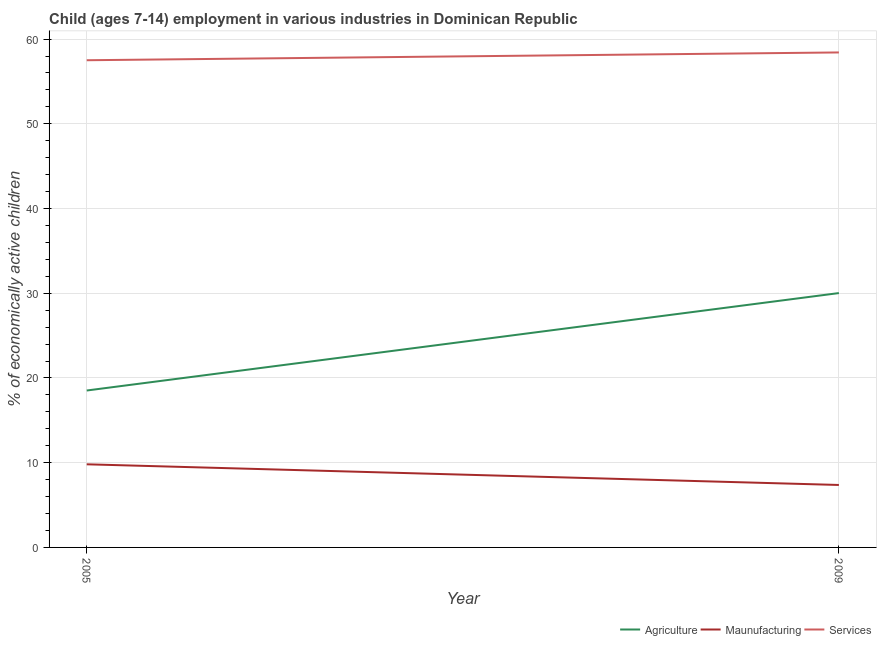How many different coloured lines are there?
Your response must be concise. 3. Does the line corresponding to percentage of economically active children in agriculture intersect with the line corresponding to percentage of economically active children in services?
Provide a succinct answer. No. What is the percentage of economically active children in agriculture in 2005?
Your answer should be very brief. 18.52. Across all years, what is the maximum percentage of economically active children in services?
Offer a very short reply. 58.42. Across all years, what is the minimum percentage of economically active children in services?
Offer a very short reply. 57.5. What is the total percentage of economically active children in manufacturing in the graph?
Your answer should be compact. 17.18. What is the difference between the percentage of economically active children in agriculture in 2005 and the percentage of economically active children in services in 2009?
Keep it short and to the point. -39.9. What is the average percentage of economically active children in services per year?
Give a very brief answer. 57.96. In the year 2009, what is the difference between the percentage of economically active children in services and percentage of economically active children in manufacturing?
Provide a succinct answer. 51.05. What is the ratio of the percentage of economically active children in agriculture in 2005 to that in 2009?
Offer a terse response. 0.62. In how many years, is the percentage of economically active children in services greater than the average percentage of economically active children in services taken over all years?
Make the answer very short. 1. Is it the case that in every year, the sum of the percentage of economically active children in agriculture and percentage of economically active children in manufacturing is greater than the percentage of economically active children in services?
Your answer should be very brief. No. Does the percentage of economically active children in services monotonically increase over the years?
Provide a succinct answer. Yes. How many lines are there?
Offer a terse response. 3. How many years are there in the graph?
Your answer should be very brief. 2. What is the difference between two consecutive major ticks on the Y-axis?
Offer a terse response. 10. Are the values on the major ticks of Y-axis written in scientific E-notation?
Provide a short and direct response. No. Does the graph contain grids?
Your response must be concise. Yes. How many legend labels are there?
Your response must be concise. 3. What is the title of the graph?
Ensure brevity in your answer.  Child (ages 7-14) employment in various industries in Dominican Republic. Does "Industrial Nitrous Oxide" appear as one of the legend labels in the graph?
Your response must be concise. No. What is the label or title of the X-axis?
Ensure brevity in your answer.  Year. What is the label or title of the Y-axis?
Your response must be concise. % of economically active children. What is the % of economically active children in Agriculture in 2005?
Your answer should be very brief. 18.52. What is the % of economically active children of Maunufacturing in 2005?
Ensure brevity in your answer.  9.81. What is the % of economically active children of Services in 2005?
Provide a short and direct response. 57.5. What is the % of economically active children in Agriculture in 2009?
Your answer should be very brief. 30.02. What is the % of economically active children in Maunufacturing in 2009?
Make the answer very short. 7.37. What is the % of economically active children in Services in 2009?
Your response must be concise. 58.42. Across all years, what is the maximum % of economically active children in Agriculture?
Give a very brief answer. 30.02. Across all years, what is the maximum % of economically active children of Maunufacturing?
Offer a very short reply. 9.81. Across all years, what is the maximum % of economically active children of Services?
Make the answer very short. 58.42. Across all years, what is the minimum % of economically active children in Agriculture?
Your answer should be compact. 18.52. Across all years, what is the minimum % of economically active children of Maunufacturing?
Keep it short and to the point. 7.37. Across all years, what is the minimum % of economically active children of Services?
Provide a succinct answer. 57.5. What is the total % of economically active children of Agriculture in the graph?
Your response must be concise. 48.54. What is the total % of economically active children of Maunufacturing in the graph?
Your answer should be compact. 17.18. What is the total % of economically active children of Services in the graph?
Ensure brevity in your answer.  115.92. What is the difference between the % of economically active children in Agriculture in 2005 and that in 2009?
Provide a short and direct response. -11.5. What is the difference between the % of economically active children in Maunufacturing in 2005 and that in 2009?
Offer a terse response. 2.44. What is the difference between the % of economically active children in Services in 2005 and that in 2009?
Make the answer very short. -0.92. What is the difference between the % of economically active children of Agriculture in 2005 and the % of economically active children of Maunufacturing in 2009?
Your answer should be very brief. 11.15. What is the difference between the % of economically active children of Agriculture in 2005 and the % of economically active children of Services in 2009?
Provide a short and direct response. -39.9. What is the difference between the % of economically active children in Maunufacturing in 2005 and the % of economically active children in Services in 2009?
Your response must be concise. -48.61. What is the average % of economically active children in Agriculture per year?
Provide a short and direct response. 24.27. What is the average % of economically active children of Maunufacturing per year?
Provide a succinct answer. 8.59. What is the average % of economically active children of Services per year?
Keep it short and to the point. 57.96. In the year 2005, what is the difference between the % of economically active children in Agriculture and % of economically active children in Maunufacturing?
Offer a very short reply. 8.71. In the year 2005, what is the difference between the % of economically active children in Agriculture and % of economically active children in Services?
Provide a succinct answer. -38.98. In the year 2005, what is the difference between the % of economically active children of Maunufacturing and % of economically active children of Services?
Your answer should be compact. -47.69. In the year 2009, what is the difference between the % of economically active children in Agriculture and % of economically active children in Maunufacturing?
Keep it short and to the point. 22.65. In the year 2009, what is the difference between the % of economically active children of Agriculture and % of economically active children of Services?
Give a very brief answer. -28.4. In the year 2009, what is the difference between the % of economically active children of Maunufacturing and % of economically active children of Services?
Your answer should be very brief. -51.05. What is the ratio of the % of economically active children in Agriculture in 2005 to that in 2009?
Provide a short and direct response. 0.62. What is the ratio of the % of economically active children of Maunufacturing in 2005 to that in 2009?
Your answer should be compact. 1.33. What is the ratio of the % of economically active children in Services in 2005 to that in 2009?
Offer a very short reply. 0.98. What is the difference between the highest and the second highest % of economically active children of Agriculture?
Offer a very short reply. 11.5. What is the difference between the highest and the second highest % of economically active children of Maunufacturing?
Your answer should be compact. 2.44. What is the difference between the highest and the second highest % of economically active children of Services?
Provide a succinct answer. 0.92. What is the difference between the highest and the lowest % of economically active children of Maunufacturing?
Provide a succinct answer. 2.44. What is the difference between the highest and the lowest % of economically active children in Services?
Keep it short and to the point. 0.92. 